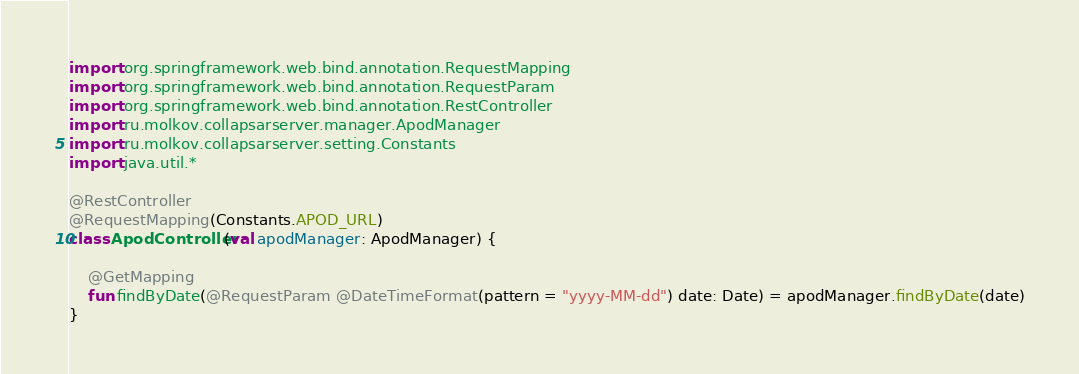<code> <loc_0><loc_0><loc_500><loc_500><_Kotlin_>import org.springframework.web.bind.annotation.RequestMapping
import org.springframework.web.bind.annotation.RequestParam
import org.springframework.web.bind.annotation.RestController
import ru.molkov.collapsarserver.manager.ApodManager
import ru.molkov.collapsarserver.setting.Constants
import java.util.*

@RestController
@RequestMapping(Constants.APOD_URL)
class ApodController(val apodManager: ApodManager) {

    @GetMapping
    fun findByDate(@RequestParam @DateTimeFormat(pattern = "yyyy-MM-dd") date: Date) = apodManager.findByDate(date)
}</code> 